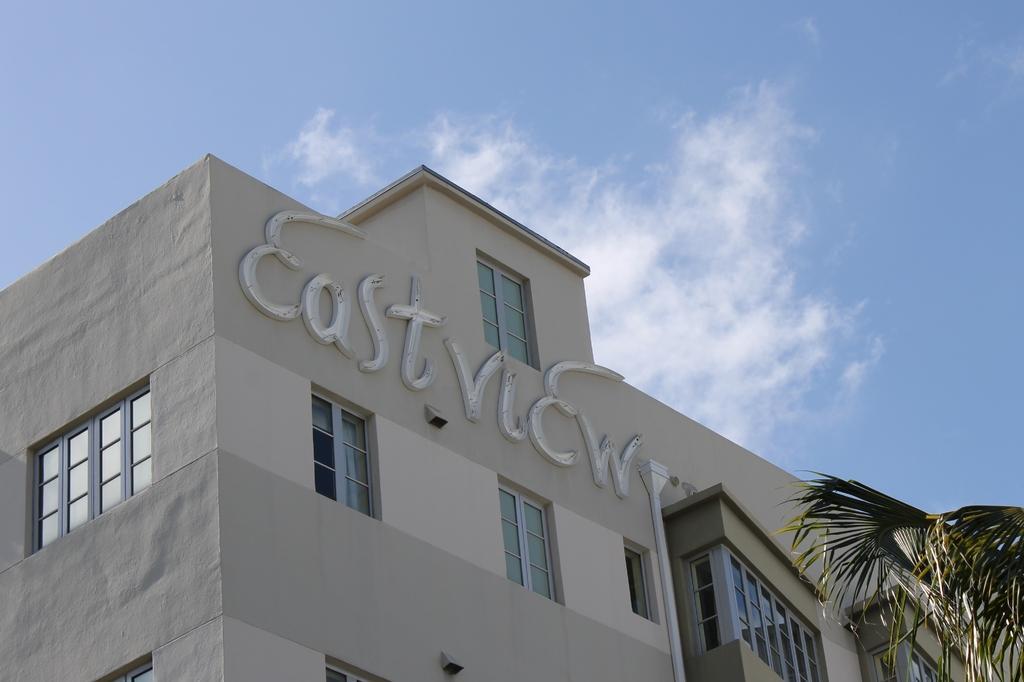In one or two sentences, can you explain what this image depicts? In this image there is a building. In the right there is a tree. The sky is cloudy. 